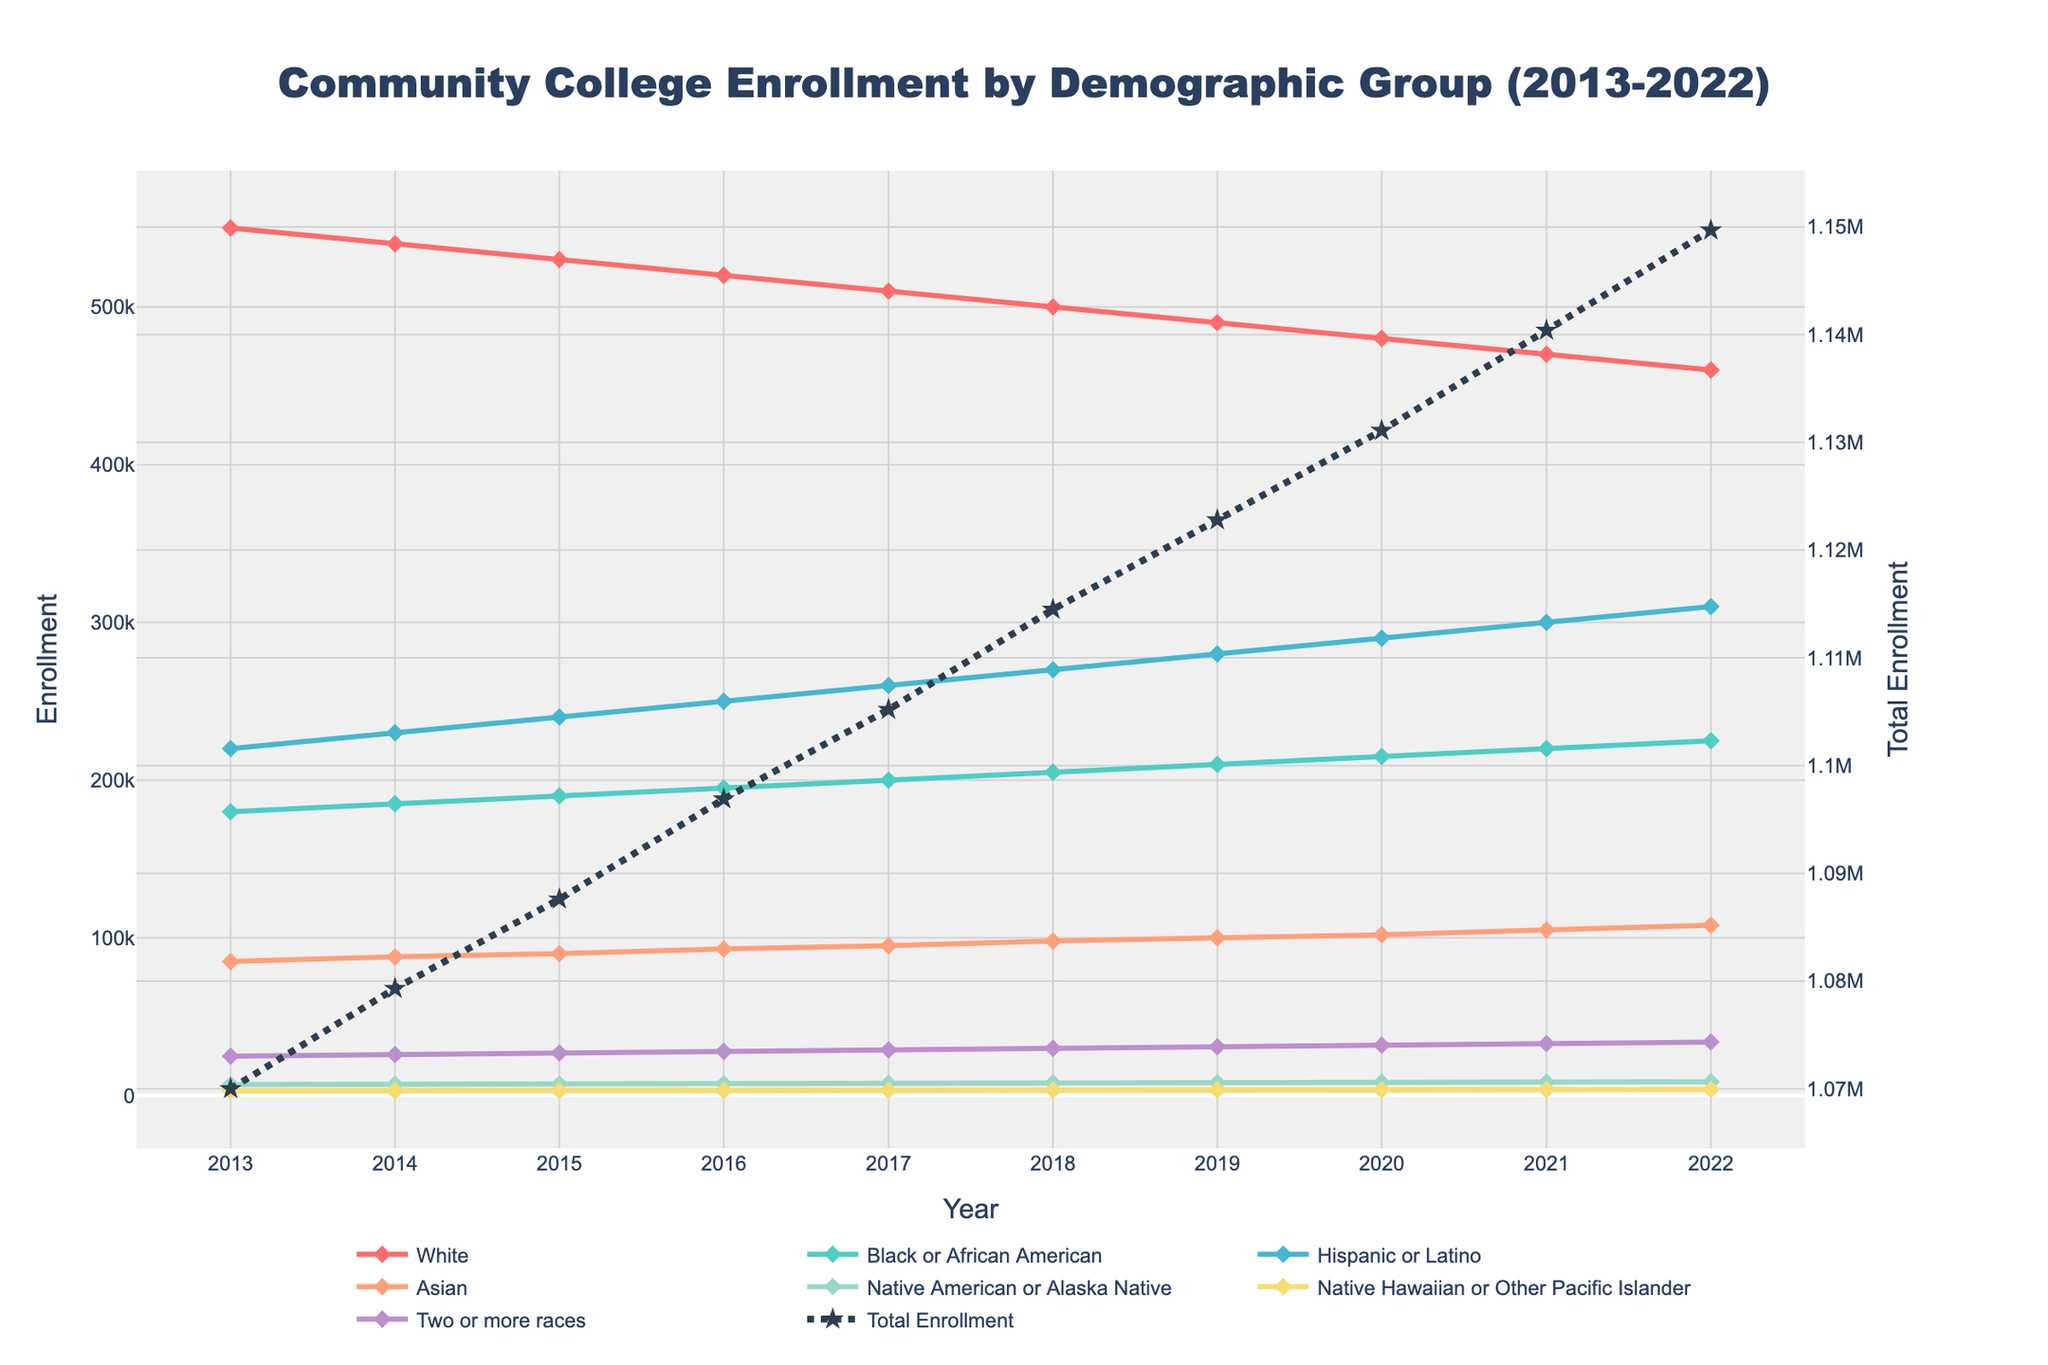What is the title of the figure? The title is usually found at the top of the figure in a larger font size. In this case, it's written as "Community College Enrollment by Demographic Group (2013-2022)".
Answer: Community College Enrollment by Demographic Group (2013-2022) How many demographic groups are shown in the figure? The figure uses different colored lines and markers to represent each demographic group. Counting these, we find there are 7 demographic groups represented.
Answer: 7 Which demographic group has the highest enrollment rate in 2022? By examining the endpoints of the lines on the plot for 2022, we observe that the "Hispanic or Latino" group has the highest enrollment rate.
Answer: Hispanic or Latino How has the total enrollment trend changed from 2013 to 2022? By following the dot-dashed line representing total enrollment from 2013 to 2022, it's clear that the total enrollment has been decreasing over this period.
Answer: Decreasing What is the enrollment rate for the "Black or African American" group in 2015? Locating the "Black or African American" line on the plot and finding the data point for 2015, we see that the enrollment rate is 190,000.
Answer: 190,000 Which two demographic groups showed the most significant enrollment increase over the decade? Observing the lines for each group, the "Hispanic or Latino" group shows the most significant increase, followed by the "Black or African American" group.
Answer: Hispanic or Latino, Black or African American What is the difference in enrollment rates between the "White" and "Asian" groups in 2020? Finding the data points for both "White" and "Asian" in 2020, we see that "White" had 480,000 and "Asian" had 102,000. The difference is 480,000 - 102,000 = 378,000.
Answer: 378,000 Which demographic group had the most consistent enrollment rate over the years? Examining the nature of the lines for each group, the "Asian" group's line appears to be the most steady and straight, indicating a consistent rate over time.
Answer: Asian What was the average enrollment rate of the "Native American or Alaska Native" group from 2013 to 2022? Adding up the enrollment rates for "Native American or Alaska Native" from 2013 to 2022: 7000 + 7200 + 7400 + 7600 + 7800 + 8000 + 8200 + 8400 + 8600 + 8800 = 78,000, then dividing by 10 gives 7800.
Answer: 7800 Which year had the highest total enrollment? Observing the dot-dashed line representing total enrollment, the highest point occurs in 2013.
Answer: 2013 